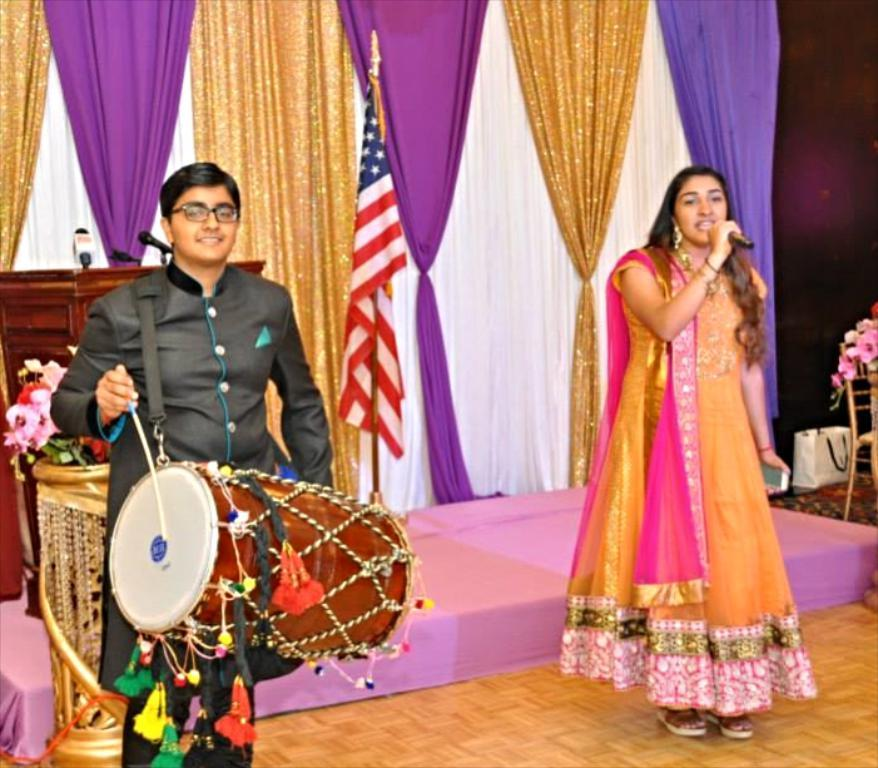What is the man in the image holding? The man is holding a drum. What is the woman in the image doing? The woman is singing with the help of a microphone. What structure can be seen in the image? There is a podium in the image. What is the flag associated with in the image? The flag is present in the image. What type of produce is being harvested in the image? There is no produce or harvesting activity present in the image. What day of the week is depicted in the image? The day of the week is not mentioned or depicted in the image. 